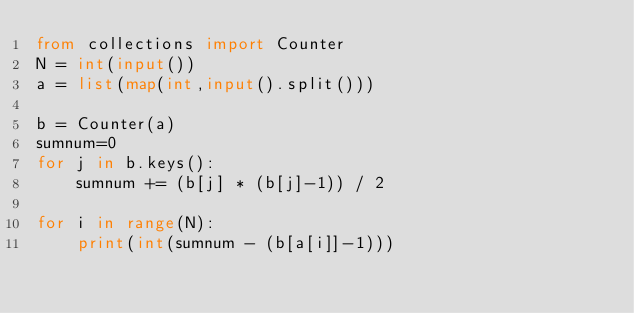Convert code to text. <code><loc_0><loc_0><loc_500><loc_500><_Python_>from collections import Counter
N = int(input())
a = list(map(int,input().split()))

b = Counter(a)
sumnum=0
for j in b.keys(): 
    sumnum += (b[j] * (b[j]-1)) / 2

for i in range(N):
    print(int(sumnum - (b[a[i]]-1)))

</code> 